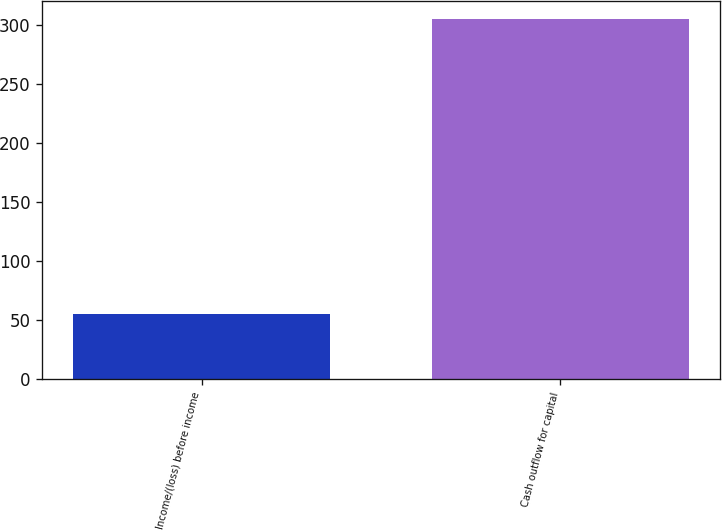Convert chart to OTSL. <chart><loc_0><loc_0><loc_500><loc_500><bar_chart><fcel>Income/(loss) before income<fcel>Cash outflow for capital<nl><fcel>55<fcel>305<nl></chart> 